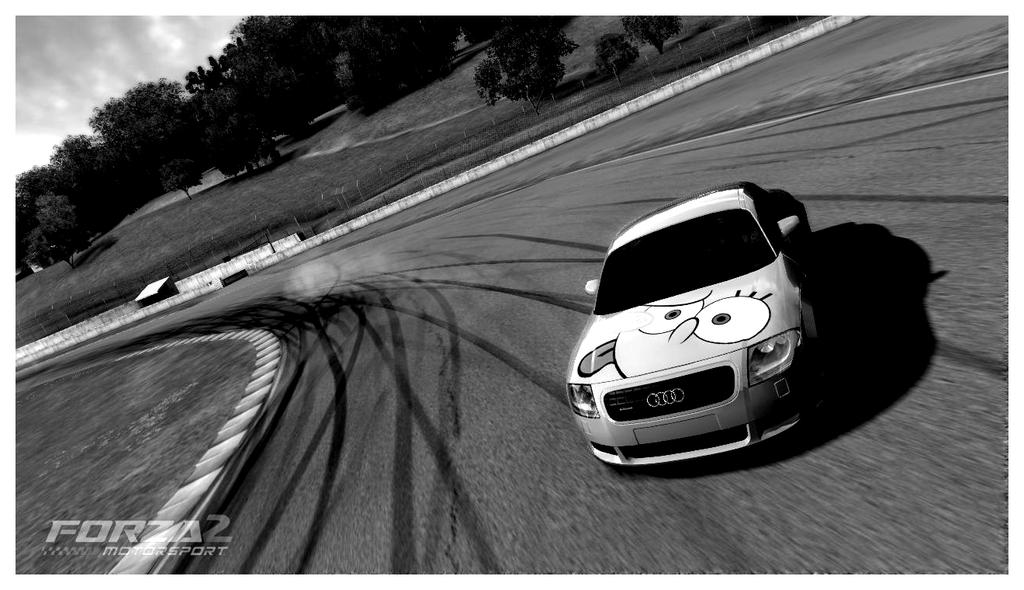What is the main feature of the image? There is a road in the image. What type of vehicle can be seen on the road? There is a white color car in the image. What type of vegetation is present in the image? There is grass and trees in the image. What can be seen in the background of the image? The sky is visible in the image, and clouds are present in the sky. How would you describe the lighting in the image? The image is slightly dark. What type of base is used to transport the car in the image? There is no base present in the image, and the car is already on the road. How does the grass slip on the trees in the image? The grass does not slip on the trees in the image; they are separate elements in the scene. 